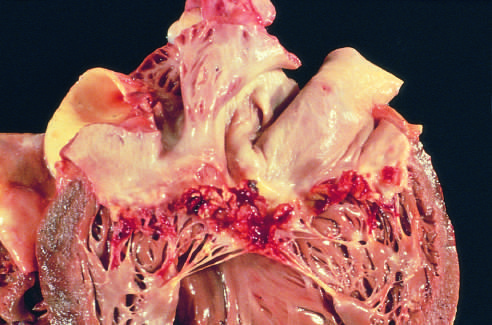s subacute endocarditis caused by streptococcus viridans on a previously myxomatous mitral valve?
Answer the question using a single word or phrase. Yes 